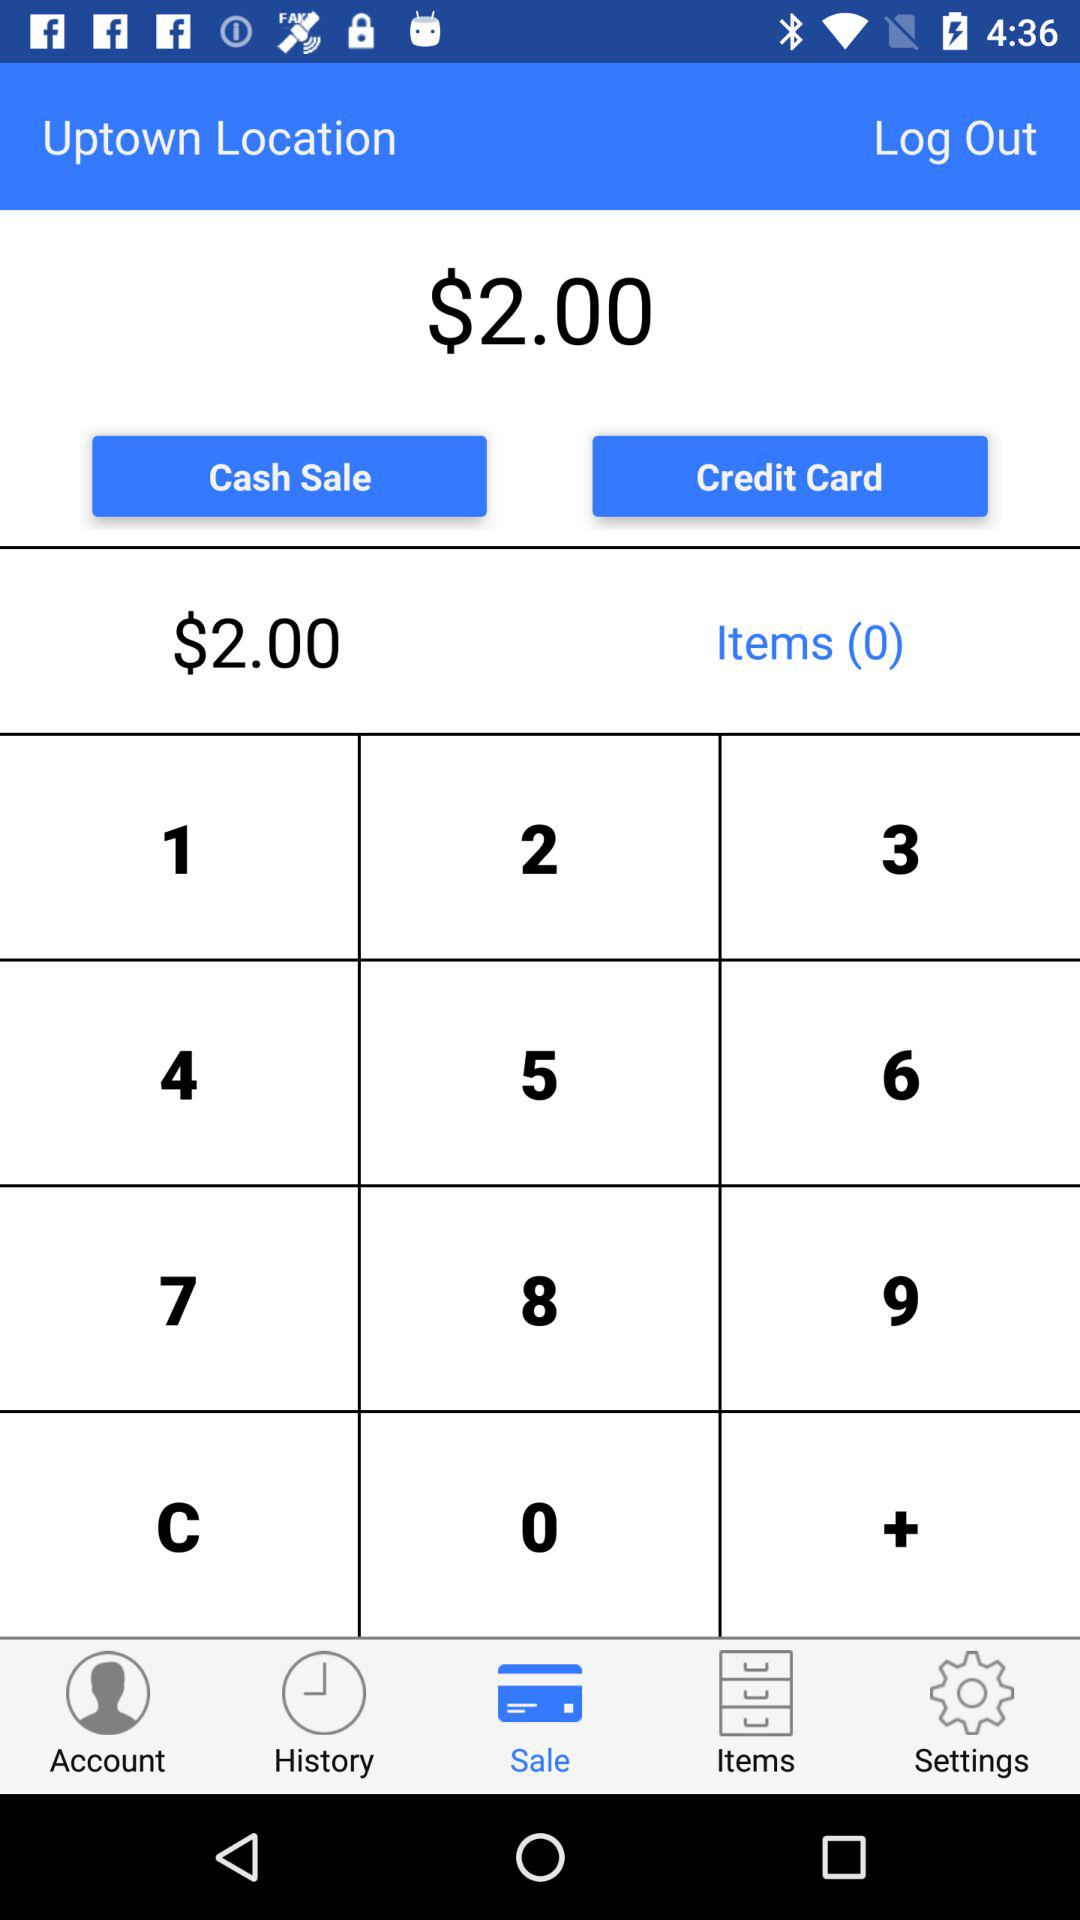How much is the total amount due?
Answer the question using a single word or phrase. $2.00 